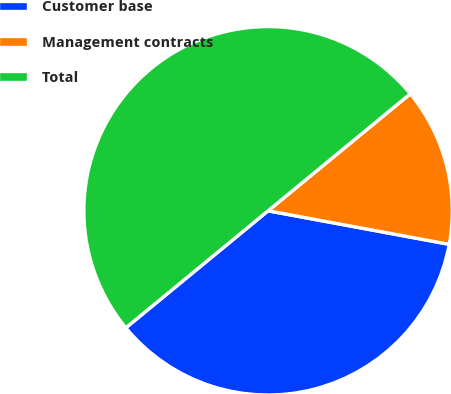Convert chart. <chart><loc_0><loc_0><loc_500><loc_500><pie_chart><fcel>Customer base<fcel>Management contracts<fcel>Total<nl><fcel>36.13%<fcel>13.87%<fcel>50.0%<nl></chart> 